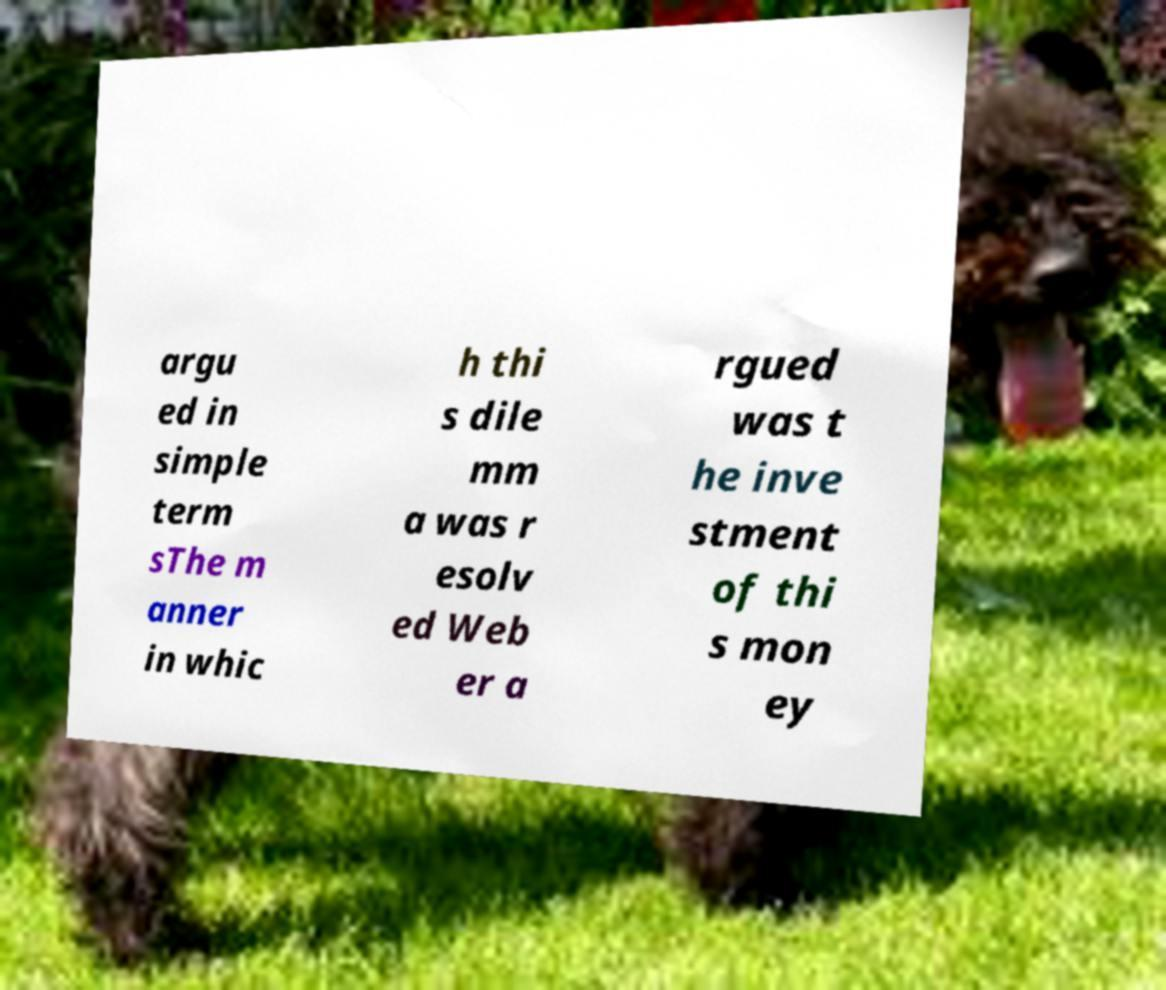Can you accurately transcribe the text from the provided image for me? argu ed in simple term sThe m anner in whic h thi s dile mm a was r esolv ed Web er a rgued was t he inve stment of thi s mon ey 